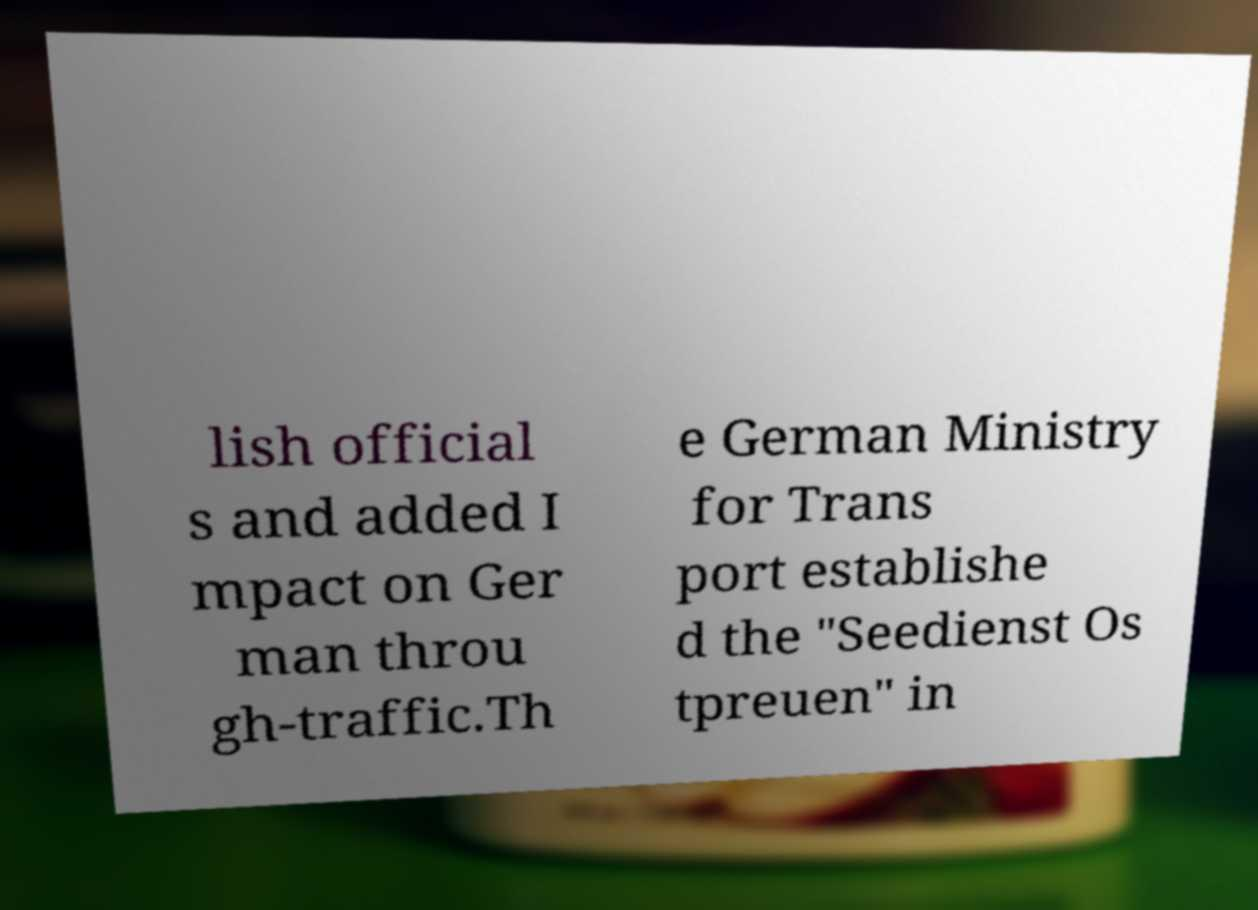Please read and relay the text visible in this image. What does it say? lish official s and added I mpact on Ger man throu gh-traffic.Th e German Ministry for Trans port establishe d the "Seedienst Os tpreuen" in 